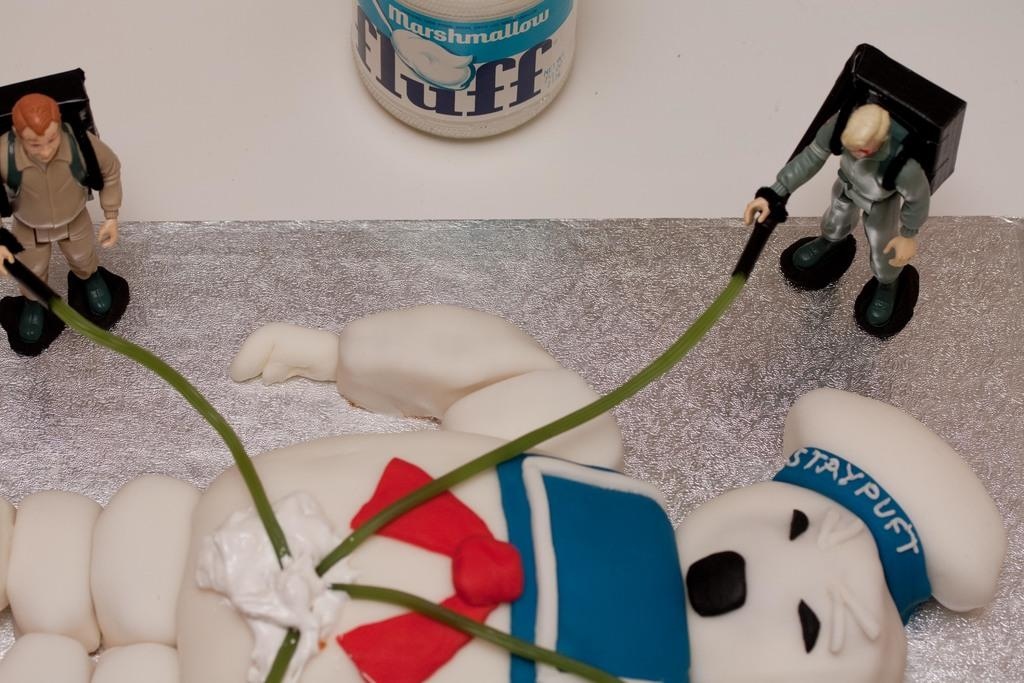What is the main subject of the picture? The main subject of the picture is a doll. Are there any other dolls in the picture? Yes, there are small dolls in the picture. What is connected to the doll? Cables are connected to the doll. On what surface is the doll placed? The doll is placed on a silver surface. What is the plot of the story involving the doll's throat in the image? There is no story or throat mentioned in the image; it simply shows a doll with cables connected to it on a silver surface. 